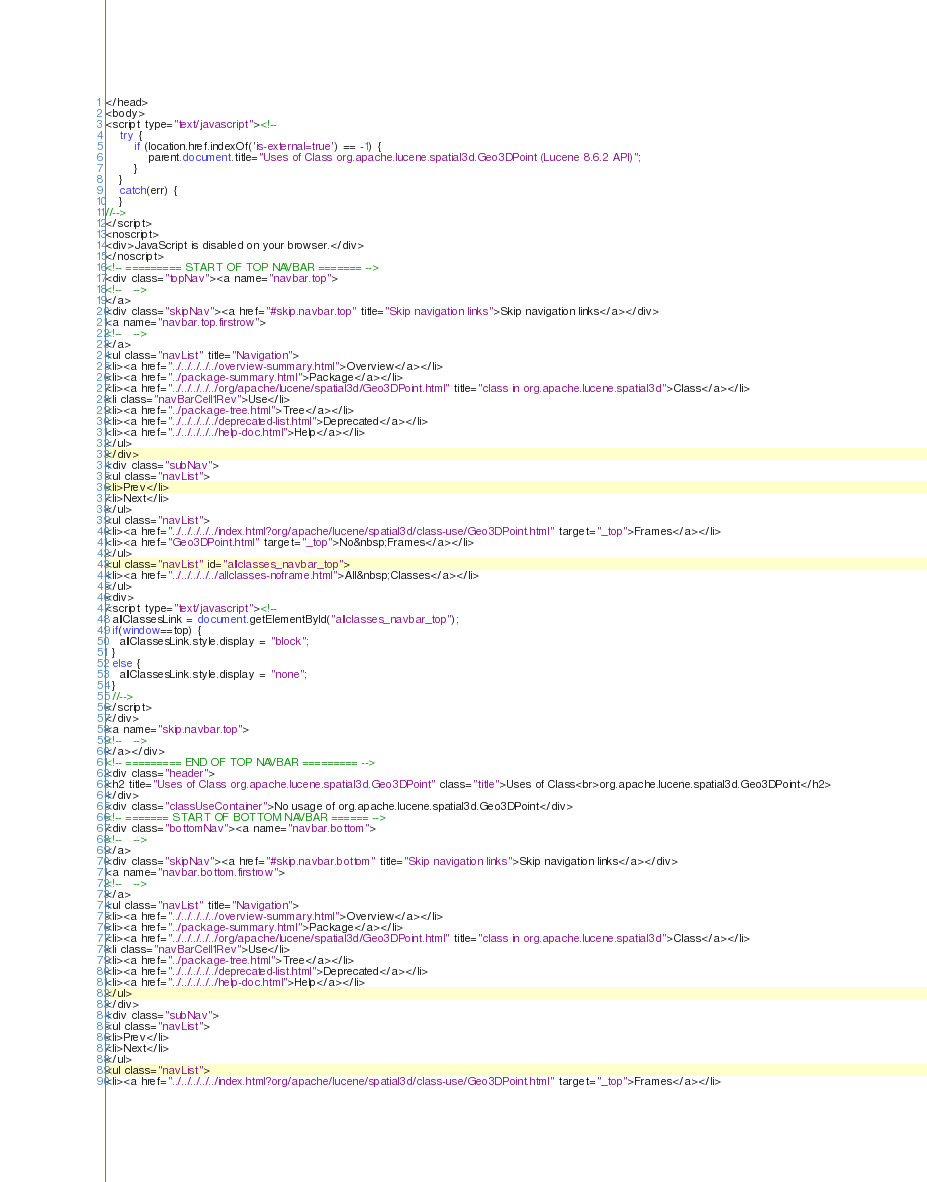Convert code to text. <code><loc_0><loc_0><loc_500><loc_500><_HTML_></head>
<body>
<script type="text/javascript"><!--
    try {
        if (location.href.indexOf('is-external=true') == -1) {
            parent.document.title="Uses of Class org.apache.lucene.spatial3d.Geo3DPoint (Lucene 8.6.2 API)";
        }
    }
    catch(err) {
    }
//-->
</script>
<noscript>
<div>JavaScript is disabled on your browser.</div>
</noscript>
<!-- ========= START OF TOP NAVBAR ======= -->
<div class="topNav"><a name="navbar.top">
<!--   -->
</a>
<div class="skipNav"><a href="#skip.navbar.top" title="Skip navigation links">Skip navigation links</a></div>
<a name="navbar.top.firstrow">
<!--   -->
</a>
<ul class="navList" title="Navigation">
<li><a href="../../../../../overview-summary.html">Overview</a></li>
<li><a href="../package-summary.html">Package</a></li>
<li><a href="../../../../../org/apache/lucene/spatial3d/Geo3DPoint.html" title="class in org.apache.lucene.spatial3d">Class</a></li>
<li class="navBarCell1Rev">Use</li>
<li><a href="../package-tree.html">Tree</a></li>
<li><a href="../../../../../deprecated-list.html">Deprecated</a></li>
<li><a href="../../../../../help-doc.html">Help</a></li>
</ul>
</div>
<div class="subNav">
<ul class="navList">
<li>Prev</li>
<li>Next</li>
</ul>
<ul class="navList">
<li><a href="../../../../../index.html?org/apache/lucene/spatial3d/class-use/Geo3DPoint.html" target="_top">Frames</a></li>
<li><a href="Geo3DPoint.html" target="_top">No&nbsp;Frames</a></li>
</ul>
<ul class="navList" id="allclasses_navbar_top">
<li><a href="../../../../../allclasses-noframe.html">All&nbsp;Classes</a></li>
</ul>
<div>
<script type="text/javascript"><!--
  allClassesLink = document.getElementById("allclasses_navbar_top");
  if(window==top) {
    allClassesLink.style.display = "block";
  }
  else {
    allClassesLink.style.display = "none";
  }
  //-->
</script>
</div>
<a name="skip.navbar.top">
<!--   -->
</a></div>
<!-- ========= END OF TOP NAVBAR ========= -->
<div class="header">
<h2 title="Uses of Class org.apache.lucene.spatial3d.Geo3DPoint" class="title">Uses of Class<br>org.apache.lucene.spatial3d.Geo3DPoint</h2>
</div>
<div class="classUseContainer">No usage of org.apache.lucene.spatial3d.Geo3DPoint</div>
<!-- ======= START OF BOTTOM NAVBAR ====== -->
<div class="bottomNav"><a name="navbar.bottom">
<!--   -->
</a>
<div class="skipNav"><a href="#skip.navbar.bottom" title="Skip navigation links">Skip navigation links</a></div>
<a name="navbar.bottom.firstrow">
<!--   -->
</a>
<ul class="navList" title="Navigation">
<li><a href="../../../../../overview-summary.html">Overview</a></li>
<li><a href="../package-summary.html">Package</a></li>
<li><a href="../../../../../org/apache/lucene/spatial3d/Geo3DPoint.html" title="class in org.apache.lucene.spatial3d">Class</a></li>
<li class="navBarCell1Rev">Use</li>
<li><a href="../package-tree.html">Tree</a></li>
<li><a href="../../../../../deprecated-list.html">Deprecated</a></li>
<li><a href="../../../../../help-doc.html">Help</a></li>
</ul>
</div>
<div class="subNav">
<ul class="navList">
<li>Prev</li>
<li>Next</li>
</ul>
<ul class="navList">
<li><a href="../../../../../index.html?org/apache/lucene/spatial3d/class-use/Geo3DPoint.html" target="_top">Frames</a></li></code> 